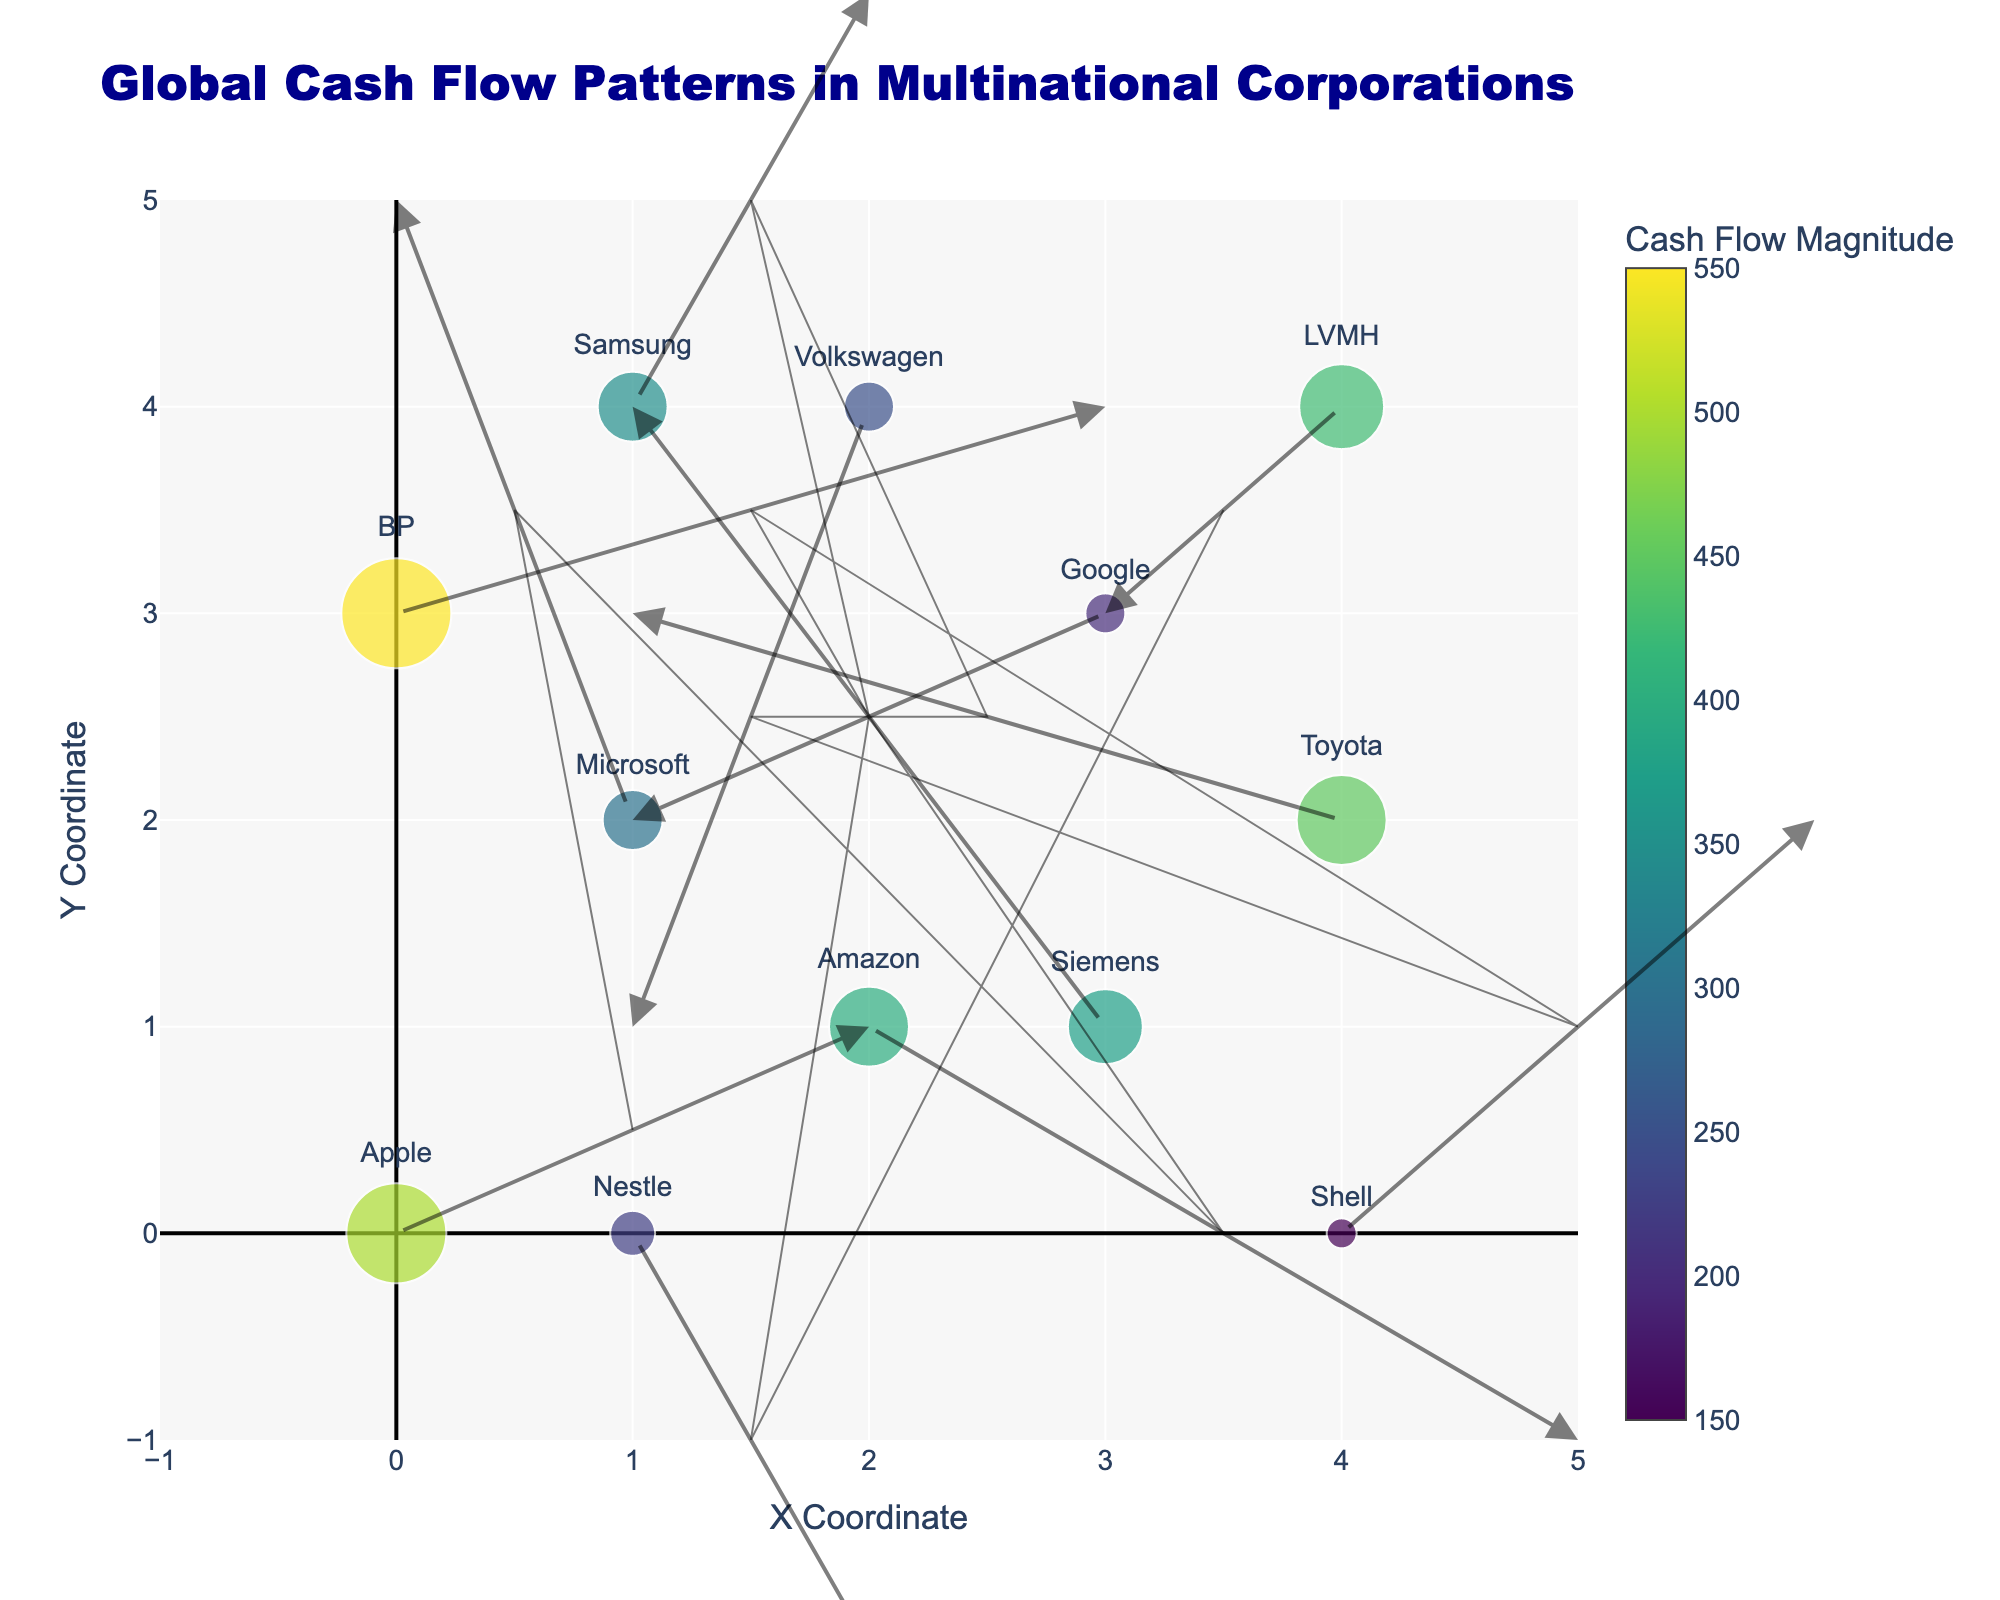What's the title of the plot? The title is usually at the top of the plot. Look for the largest text with a distinct font color and size that indicates the overview of the plot.
Answer: Global Cash Flow Patterns in Multinational Corporations How many corporations are represented in the plot? Count the unique data points represented, which correspond to the number of companies listed. Each data point usually has an associated label or marker.
Answer: 12 Which corporation has the largest cash flow magnitude? Identify the corporation associated with the largest marker size (circle size), and check the color scale for verification. Look for the largest value in the color bar.
Answer: BP Which company is associated with the arrow pointing directly southeast (towards positive x and positive y)? Look at the direction of the arrows to find the one pointing southeast (+x, +y). Trace back to identify the company at the tail of this arrow.
Answer: Shell What is the general direction of cash flow for Amazon? Find the specific data point labeled "Amazon" and look at the direction its associated arrow is pointing.
Answer: Southeast How does the cash flow magnitude of Siemens compare to that of Nestle? Compare the size and color of the markers for Siemens and Nestle, which represent the cash flow magnitudes. Siemens' marker corresponds to 375, while Nestle's corresponds to 225.
Answer: Siemens has a larger magnitude than Nestle How many corporations have an outward cash flow from a lower to upper position on the vertical axis (positive y direction)? Identify the arrows pointing upwards on the y-axis from each data point. Count the number of these arrows.
Answer: 5 What are the coordinates and cash flow magnitudes of the corporations located at (4, 4) and (4, 2)? Locate the points on the coordinate grid: (4, 4) corresponds to LVMH and (4, 2) corresponds to Toyota. Check their marker sizes and the associated cash flow magnitudes from the legend.
Answer: (4, 4) LVMH: 425; (4, 2) Toyota: 450 Which corporation has the most complex cash flow movement (based on the largest combined x and y directional changes)? Calculate the sum of the absolute values of u and v for each company. The corporation with the highest sum has the most complex movement.
Answer: Microsoft Which corporation exhibits the least directional change in cash flow (smallest magnitude of u and v combined)? Calculate the sum of the absolute values of u and v for each company. The corporation with the smallest sum exhibits the least directional change.
Answer: Shell 